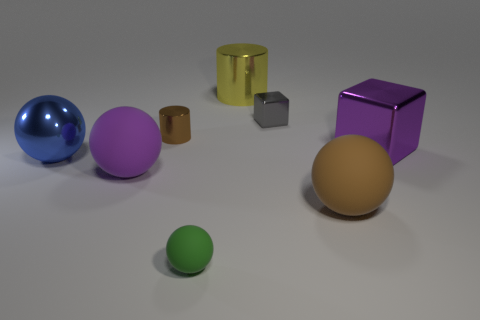What number of metal objects are both on the left side of the big purple cube and on the right side of the large blue ball?
Provide a succinct answer. 3. What material is the brown thing that is the same shape as the green object?
Your response must be concise. Rubber. There is a shiny cylinder that is right of the tiny thing in front of the brown rubber ball; how big is it?
Your answer should be very brief. Large. Is there a ball?
Your answer should be very brief. Yes. What is the small thing that is behind the purple metal object and on the left side of the yellow cylinder made of?
Your response must be concise. Metal. Is the number of tiny objects in front of the large yellow metal cylinder greater than the number of purple cubes in front of the small green thing?
Offer a very short reply. Yes. Are there any purple matte things that have the same size as the green matte thing?
Keep it short and to the point. No. There is a object right of the brown thing that is in front of the large thing that is to the right of the big brown rubber sphere; what is its size?
Your response must be concise. Large. What color is the metal ball?
Ensure brevity in your answer.  Blue. Are there more balls that are in front of the large purple ball than purple matte blocks?
Make the answer very short. Yes. 